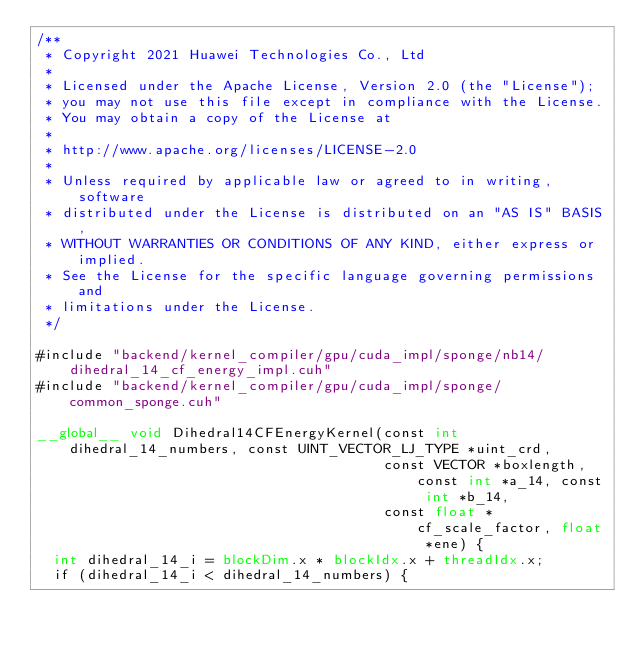Convert code to text. <code><loc_0><loc_0><loc_500><loc_500><_Cuda_>/**
 * Copyright 2021 Huawei Technologies Co., Ltd
 *
 * Licensed under the Apache License, Version 2.0 (the "License");
 * you may not use this file except in compliance with the License.
 * You may obtain a copy of the License at
 *
 * http://www.apache.org/licenses/LICENSE-2.0
 *
 * Unless required by applicable law or agreed to in writing, software
 * distributed under the License is distributed on an "AS IS" BASIS,
 * WITHOUT WARRANTIES OR CONDITIONS OF ANY KIND, either express or implied.
 * See the License for the specific language governing permissions and
 * limitations under the License.
 */

#include "backend/kernel_compiler/gpu/cuda_impl/sponge/nb14/dihedral_14_cf_energy_impl.cuh"
#include "backend/kernel_compiler/gpu/cuda_impl/sponge/common_sponge.cuh"

__global__ void Dihedral14CFEnergyKernel(const int dihedral_14_numbers, const UINT_VECTOR_LJ_TYPE *uint_crd,
                                         const VECTOR *boxlength, const int *a_14, const int *b_14,
                                         const float *cf_scale_factor, float *ene) {
  int dihedral_14_i = blockDim.x * blockIdx.x + threadIdx.x;
  if (dihedral_14_i < dihedral_14_numbers) {</code> 